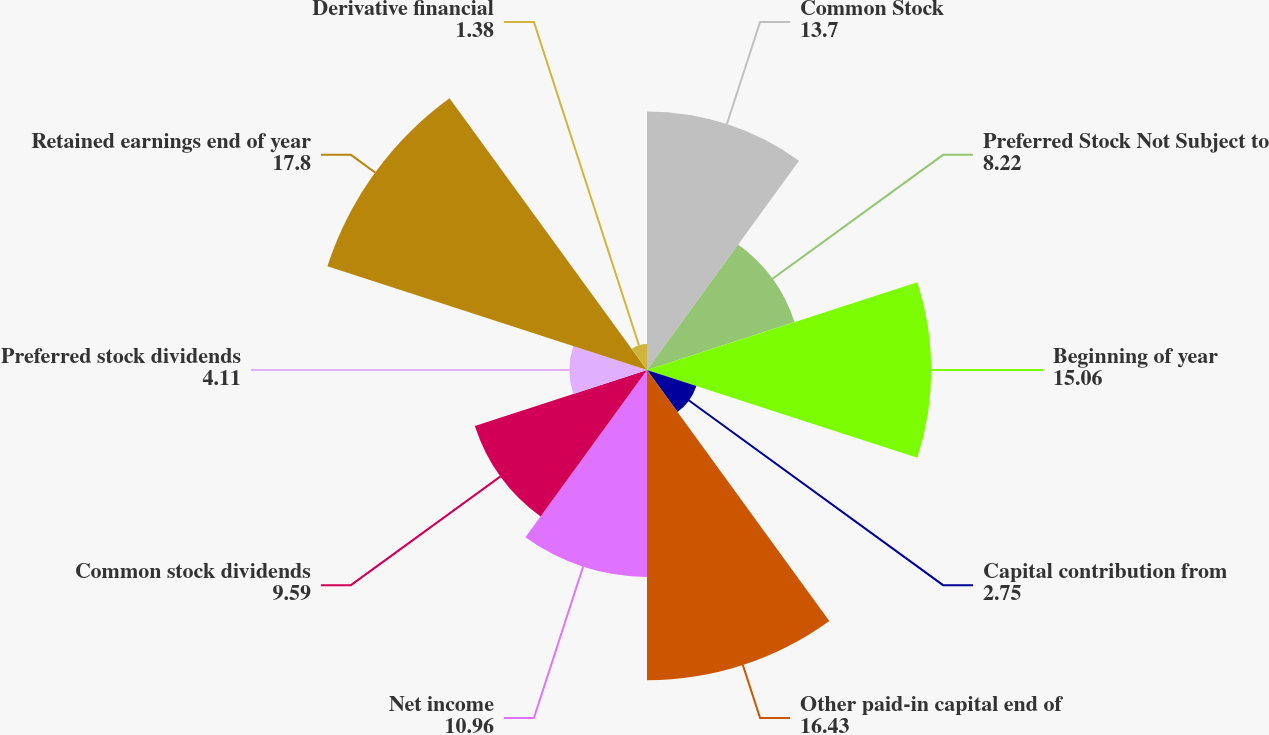Convert chart to OTSL. <chart><loc_0><loc_0><loc_500><loc_500><pie_chart><fcel>Common Stock<fcel>Preferred Stock Not Subject to<fcel>Beginning of year<fcel>Capital contribution from<fcel>Other paid-in capital end of<fcel>Net income<fcel>Common stock dividends<fcel>Preferred stock dividends<fcel>Retained earnings end of year<fcel>Derivative financial<nl><fcel>13.7%<fcel>8.22%<fcel>15.06%<fcel>2.75%<fcel>16.43%<fcel>10.96%<fcel>9.59%<fcel>4.11%<fcel>17.8%<fcel>1.38%<nl></chart> 